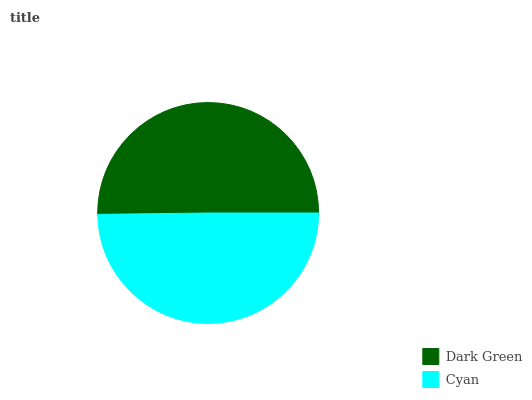Is Cyan the minimum?
Answer yes or no. Yes. Is Dark Green the maximum?
Answer yes or no. Yes. Is Cyan the maximum?
Answer yes or no. No. Is Dark Green greater than Cyan?
Answer yes or no. Yes. Is Cyan less than Dark Green?
Answer yes or no. Yes. Is Cyan greater than Dark Green?
Answer yes or no. No. Is Dark Green less than Cyan?
Answer yes or no. No. Is Dark Green the high median?
Answer yes or no. Yes. Is Cyan the low median?
Answer yes or no. Yes. Is Cyan the high median?
Answer yes or no. No. Is Dark Green the low median?
Answer yes or no. No. 